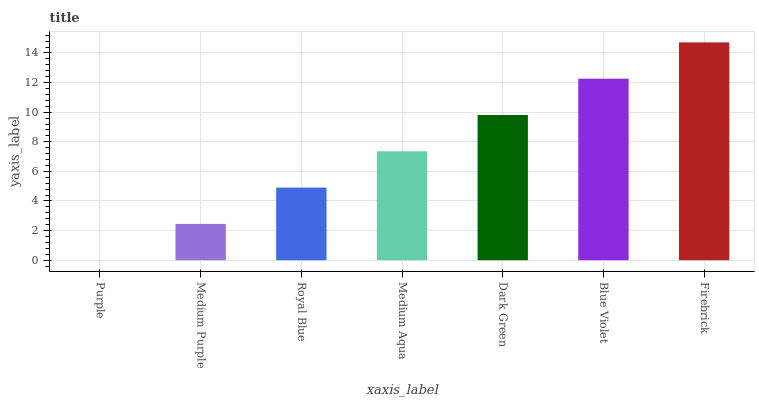Is Medium Purple the minimum?
Answer yes or no. No. Is Medium Purple the maximum?
Answer yes or no. No. Is Medium Purple greater than Purple?
Answer yes or no. Yes. Is Purple less than Medium Purple?
Answer yes or no. Yes. Is Purple greater than Medium Purple?
Answer yes or no. No. Is Medium Purple less than Purple?
Answer yes or no. No. Is Medium Aqua the high median?
Answer yes or no. Yes. Is Medium Aqua the low median?
Answer yes or no. Yes. Is Blue Violet the high median?
Answer yes or no. No. Is Purple the low median?
Answer yes or no. No. 